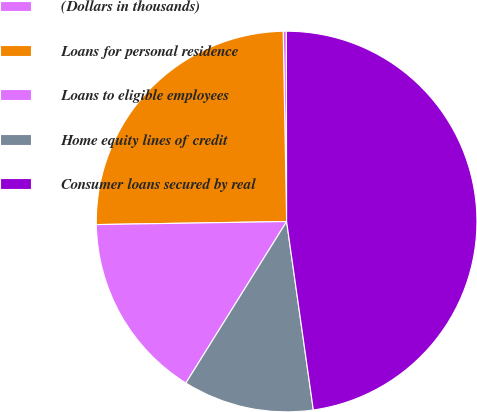Convert chart to OTSL. <chart><loc_0><loc_0><loc_500><loc_500><pie_chart><fcel>(Dollars in thousands)<fcel>Loans for personal residence<fcel>Loans to eligible employees<fcel>Home equity lines of credit<fcel>Consumer loans secured by real<nl><fcel>0.27%<fcel>24.97%<fcel>15.87%<fcel>11.12%<fcel>47.78%<nl></chart> 